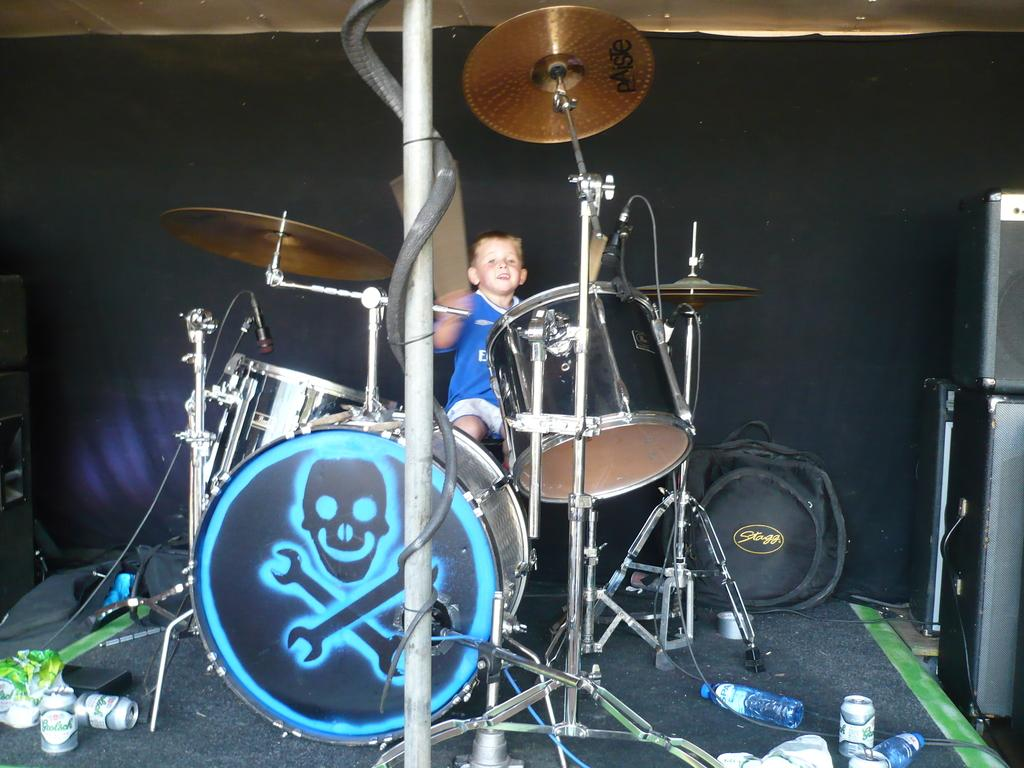What is the boy in the image doing? The boy is sitting in the image. What objects are in front of the boy? There are drums, microphones, bottles, tins, a bag, and speakers in front of the boy. What can be seen in the background of the image? There is a cloth visible in the background of the image. What is the chance of the boy swimming in the image? There is no indication of swimming or water in the image, so it cannot be determined from the image. 